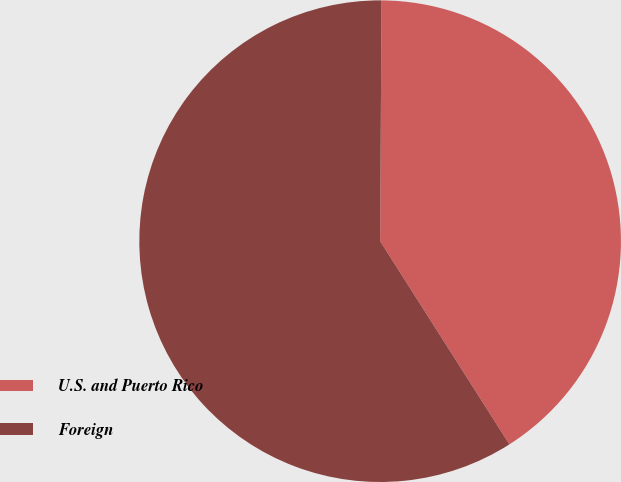Convert chart to OTSL. <chart><loc_0><loc_0><loc_500><loc_500><pie_chart><fcel>U.S. and Puerto Rico<fcel>Foreign<nl><fcel>40.89%<fcel>59.11%<nl></chart> 